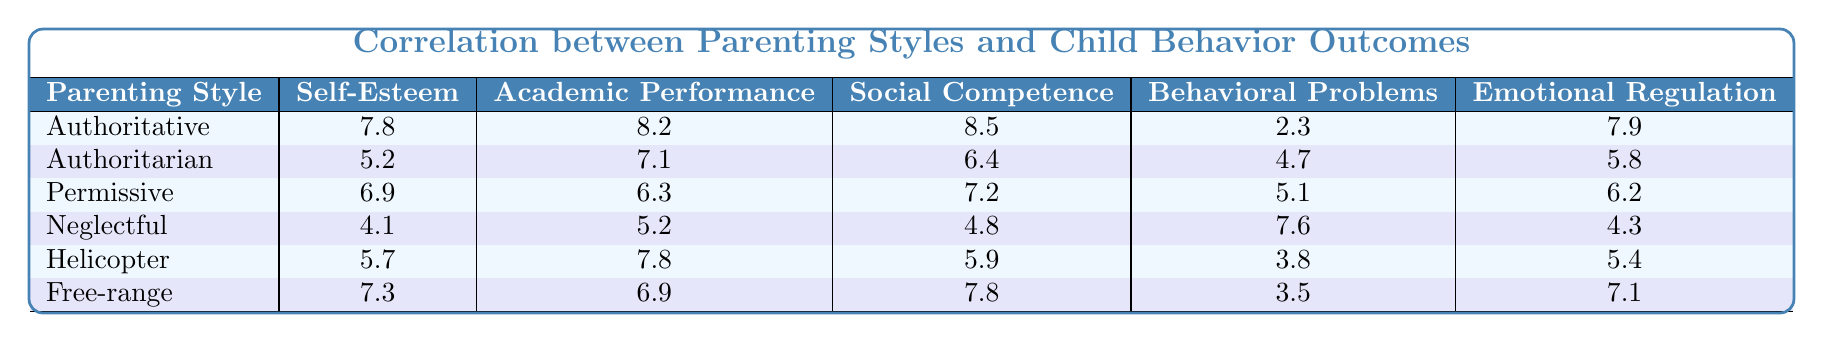What is the self-esteem score for the authoritative parenting style? From the table, under the column "Self-Esteem," the authoritative parenting style has a score of 7.8.
Answer: 7.8 Which parenting style has the highest academic performance score? Referring to the "Academic Performance" column, the authoritative parenting style has the highest score of 8.2 compared to others.
Answer: Authoritative What is the behavioral problems score for the neglectful parenting style? The table shows that the behavioral problems score for the neglectful parenting style is 7.6.
Answer: 7.6 Calculate the average self-esteem score of all parenting styles. The self-esteem scores are 7.8, 5.2, 6.9, 4.1, 5.7, and 7.3. Adding them gives a total of 37.0. Dividing by 6 (the number of styles) results in an average of 6.17.
Answer: 6.17 Does permissive parenting lead to lower behavioral problems compared to authoritarian parenting? The behavioral problems score for permissive parenting is 5.1, while for authoritarian it is 4.7. Therefore, permissive parenting leads to a higher score, indicating more behavioral problems.
Answer: No Which parenting style shows the best emotional regulation? The emotional regulation scores are: authoritative (7.9), authoritarian (5.8), permissive (6.2), neglectful (4.3), helicopter (5.4), and free-range (7.1). Authoritative has the highest score of 7.9.
Answer: Authoritative Is there a correlation between authoritative parenting style and higher self-esteem? The authoritative parenting style has a self-esteem score of 7.8, which is higher than all other styles listed, indicating a positive correlation.
Answer: Yes What is the difference in social competence scores between the authoritative and neglectful parenting styles? The social competence score for authoritative is 8.5, while for neglectful it is 4.8. The difference is 8.5 - 4.8 = 3.7.
Answer: 3.7 Identify the parenting style with the lowest emotional regulation score. The lowest score in the "Emotional Regulation" column is 4.3, which corresponds to the neglectful parenting style.
Answer: Neglectful If a child has behavioral problems of score 3.5, what parenting style is associated with it? From the table, the behavior problems score of 3.5 is associated with the free-range parenting style.
Answer: Free-range What is the total score for academic performance across all parenting styles? The academic performance scores are: 8.2, 7.1, 6.3, 5.2, 7.8, and 6.9. Adding them yields a total of 41.5.
Answer: 41.5 